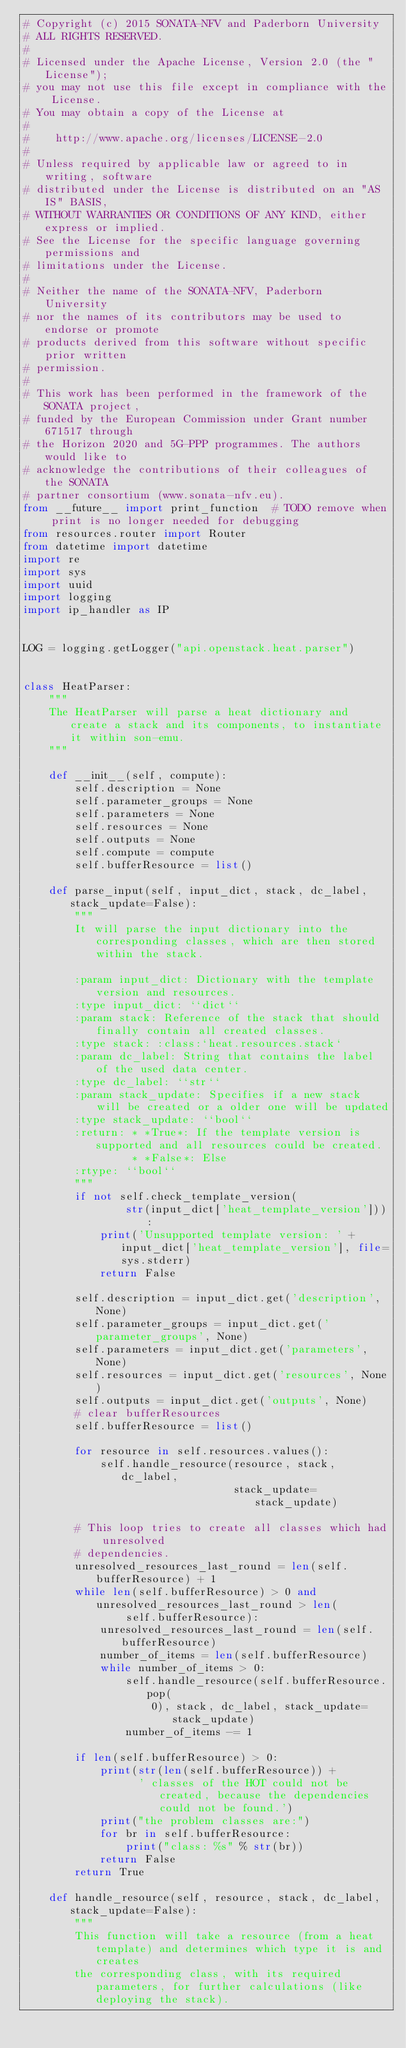Convert code to text. <code><loc_0><loc_0><loc_500><loc_500><_Python_># Copyright (c) 2015 SONATA-NFV and Paderborn University
# ALL RIGHTS RESERVED.
#
# Licensed under the Apache License, Version 2.0 (the "License");
# you may not use this file except in compliance with the License.
# You may obtain a copy of the License at
#
#    http://www.apache.org/licenses/LICENSE-2.0
#
# Unless required by applicable law or agreed to in writing, software
# distributed under the License is distributed on an "AS IS" BASIS,
# WITHOUT WARRANTIES OR CONDITIONS OF ANY KIND, either express or implied.
# See the License for the specific language governing permissions and
# limitations under the License.
#
# Neither the name of the SONATA-NFV, Paderborn University
# nor the names of its contributors may be used to endorse or promote
# products derived from this software without specific prior written
# permission.
#
# This work has been performed in the framework of the SONATA project,
# funded by the European Commission under Grant number 671517 through
# the Horizon 2020 and 5G-PPP programmes. The authors would like to
# acknowledge the contributions of their colleagues of the SONATA
# partner consortium (www.sonata-nfv.eu).
from __future__ import print_function  # TODO remove when print is no longer needed for debugging
from resources.router import Router
from datetime import datetime
import re
import sys
import uuid
import logging
import ip_handler as IP


LOG = logging.getLogger("api.openstack.heat.parser")


class HeatParser:
    """
    The HeatParser will parse a heat dictionary and create a stack and its components, to instantiate it within son-emu.
    """

    def __init__(self, compute):
        self.description = None
        self.parameter_groups = None
        self.parameters = None
        self.resources = None
        self.outputs = None
        self.compute = compute
        self.bufferResource = list()

    def parse_input(self, input_dict, stack, dc_label, stack_update=False):
        """
        It will parse the input dictionary into the corresponding classes, which are then stored within the stack.

        :param input_dict: Dictionary with the template version and resources.
        :type input_dict: ``dict``
        :param stack: Reference of the stack that should finally contain all created classes.
        :type stack: :class:`heat.resources.stack`
        :param dc_label: String that contains the label of the used data center.
        :type dc_label: ``str``
        :param stack_update: Specifies if a new stack will be created or a older one will be updated
        :type stack_update: ``bool``
        :return: * *True*: If the template version is supported and all resources could be created.
                 * *False*: Else
        :rtype: ``bool``
        """
        if not self.check_template_version(
                str(input_dict['heat_template_version'])):
            print('Unsupported template version: ' + input_dict['heat_template_version'], file=sys.stderr)
            return False

        self.description = input_dict.get('description', None)
        self.parameter_groups = input_dict.get('parameter_groups', None)
        self.parameters = input_dict.get('parameters', None)
        self.resources = input_dict.get('resources', None)
        self.outputs = input_dict.get('outputs', None)
        # clear bufferResources
        self.bufferResource = list()

        for resource in self.resources.values():
            self.handle_resource(resource, stack, dc_label,
                                 stack_update=stack_update)

        # This loop tries to create all classes which had unresolved
        # dependencies.
        unresolved_resources_last_round = len(self.bufferResource) + 1
        while len(self.bufferResource) > 0 and unresolved_resources_last_round > len(
                self.bufferResource):
            unresolved_resources_last_round = len(self.bufferResource)
            number_of_items = len(self.bufferResource)
            while number_of_items > 0:
                self.handle_resource(self.bufferResource.pop(
                    0), stack, dc_label, stack_update=stack_update)
                number_of_items -= 1

        if len(self.bufferResource) > 0:
            print(str(len(self.bufferResource)) +
                  ' classes of the HOT could not be created, because the dependencies could not be found.')
            print("the problem classes are:")
            for br in self.bufferResource:
                print("class: %s" % str(br))
            return False
        return True

    def handle_resource(self, resource, stack, dc_label, stack_update=False):
        """
        This function will take a resource (from a heat template) and determines which type it is and creates
        the corresponding class, with its required parameters, for further calculations (like deploying the stack).</code> 